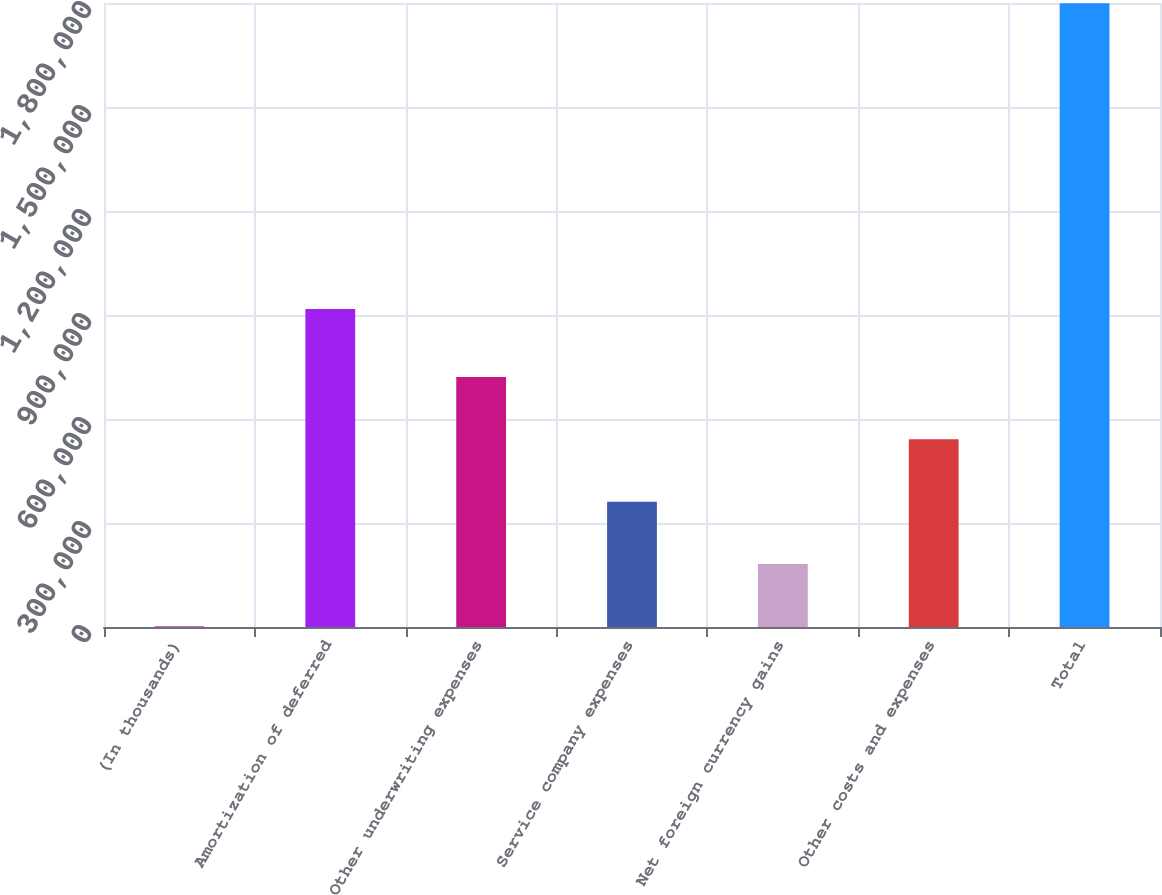Convert chart. <chart><loc_0><loc_0><loc_500><loc_500><bar_chart><fcel>(In thousands)<fcel>Amortization of deferred<fcel>Other underwriting expenses<fcel>Service company expenses<fcel>Net foreign currency gains<fcel>Other costs and expenses<fcel>Total<nl><fcel>2012<fcel>917583<fcel>721056<fcel>361534<fcel>181773<fcel>541295<fcel>1.79962e+06<nl></chart> 